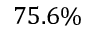<formula> <loc_0><loc_0><loc_500><loc_500>7 5 . 6 \%</formula> 